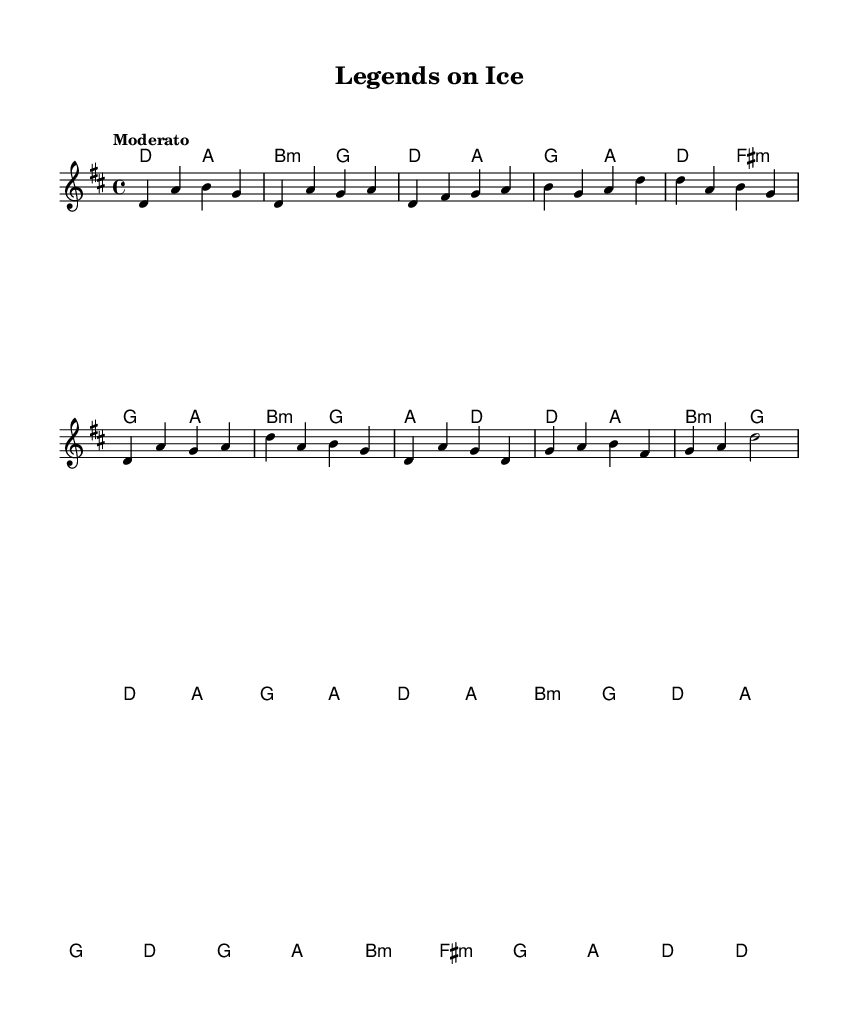What is the key signature of this music? The key signature is represented at the beginning of the staff. In this piece, there are two sharps, which indicates the key of D major.
Answer: D major What is the time signature of the piece? The time signature is located at the beginning of the music, right after the key signature. It shows 4 over 4, indicating a standard four beats per measure.
Answer: Four four What is the tempo marking for the piece? The tempo marking is found at the beginning, stating "Moderato." This indicates a moderate speed for performing the piece, typically around 108-120 beats per minute.
Answer: Moderato How many measures are in the chorus section? To find this, one would count the measures in the chorus part of the score marked by the lyrics. The chorus section consists of four measures.
Answer: Four What is the last chord in the bridge? The last chord can be identified by looking at the chord symbols above the final measures of the bridge section, which shows the chord as D.
Answer: D What theme is reflected in the lyrics? The lyrics describe iconic hockey players and their legacies, emphasizing Canadian culture and the sport of ice hockey. The overall sentiment in the lyrics captures the respect and admiration for these legends.
Answer: Ice hockey legends 